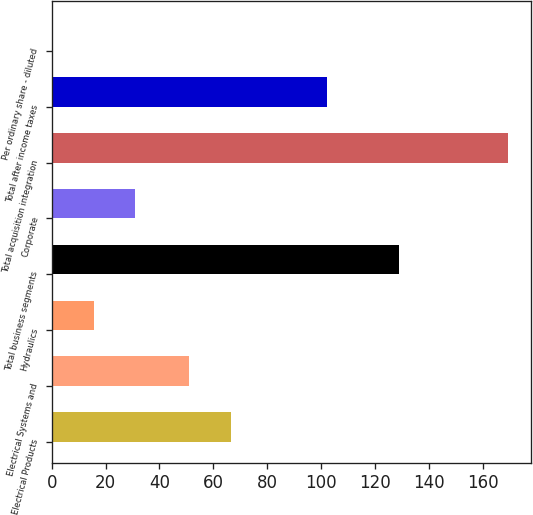Convert chart to OTSL. <chart><loc_0><loc_0><loc_500><loc_500><bar_chart><fcel>Electrical Products<fcel>Electrical Systems and<fcel>Hydraulics<fcel>Total business segments<fcel>Corporate<fcel>Total acquisition integration<fcel>Total after income taxes<fcel>Per ordinary share - diluted<nl><fcel>66.38<fcel>51<fcel>15.59<fcel>129<fcel>30.97<fcel>169.38<fcel>102<fcel>0.21<nl></chart> 